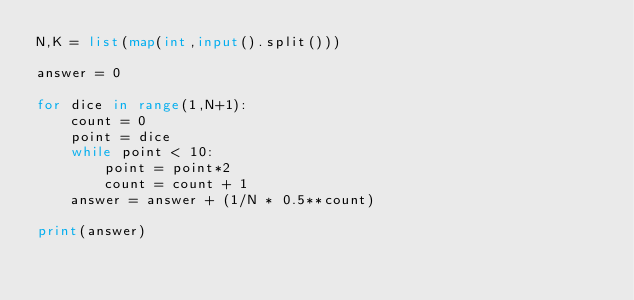<code> <loc_0><loc_0><loc_500><loc_500><_Python_>N,K = list(map(int,input().split()))

answer = 0

for dice in range(1,N+1):
    count = 0
    point = dice
    while point < 10:
        point = point*2
        count = count + 1
    answer = answer + (1/N * 0.5**count)
    
print(answer)</code> 